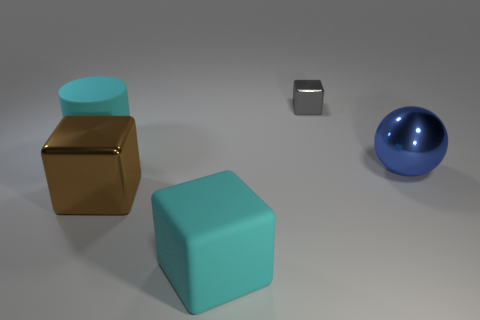Add 4 large cyan shiny cylinders. How many objects exist? 9 Subtract all cylinders. How many objects are left? 4 Subtract all cyan blocks. Subtract all big blue shiny things. How many objects are left? 3 Add 5 matte cubes. How many matte cubes are left? 6 Add 3 gray things. How many gray things exist? 4 Subtract 0 purple cubes. How many objects are left? 5 